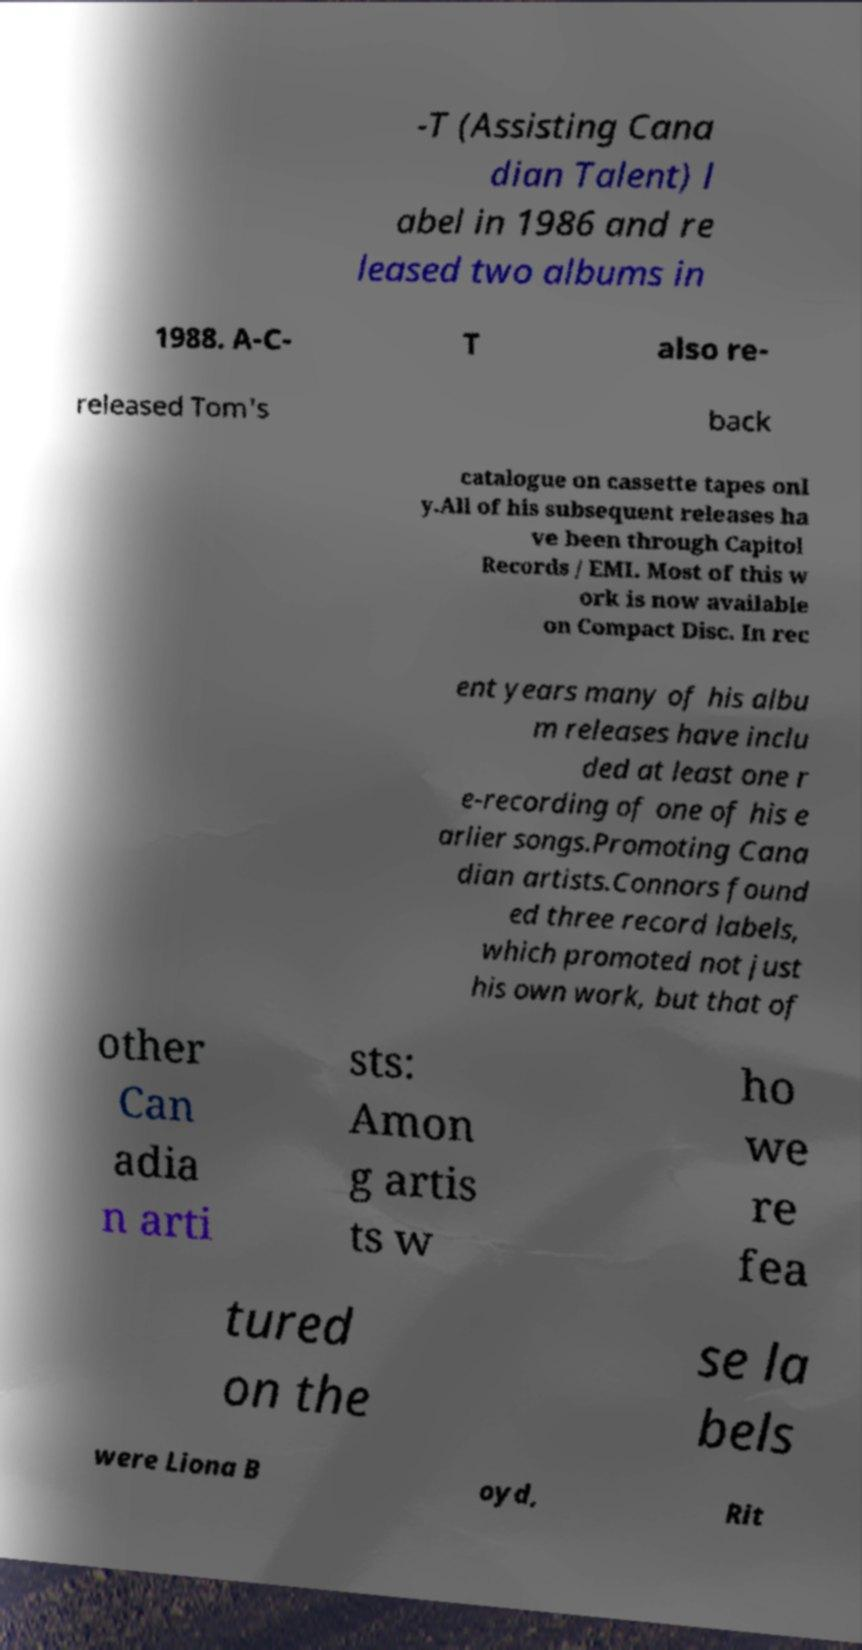For documentation purposes, I need the text within this image transcribed. Could you provide that? -T (Assisting Cana dian Talent) l abel in 1986 and re leased two albums in 1988. A-C- T also re- released Tom's back catalogue on cassette tapes onl y.All of his subsequent releases ha ve been through Capitol Records / EMI. Most of this w ork is now available on Compact Disc. In rec ent years many of his albu m releases have inclu ded at least one r e-recording of one of his e arlier songs.Promoting Cana dian artists.Connors found ed three record labels, which promoted not just his own work, but that of other Can adia n arti sts: Amon g artis ts w ho we re fea tured on the se la bels were Liona B oyd, Rit 